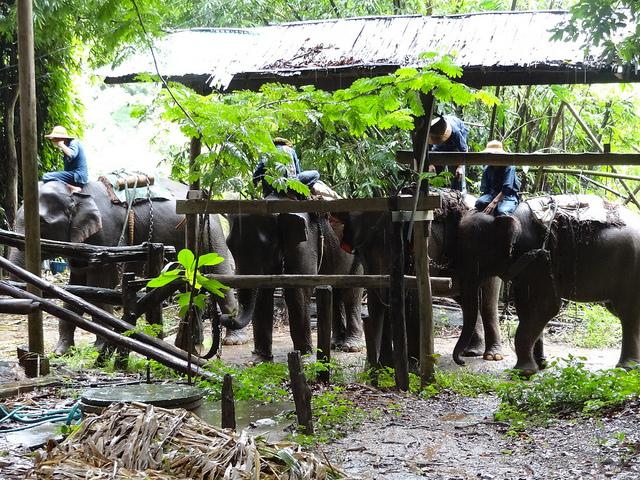What animal do you see?
Be succinct. Elephant. Could this be Asia?
Be succinct. Yes. Does this look fun?
Write a very short answer. Yes. 